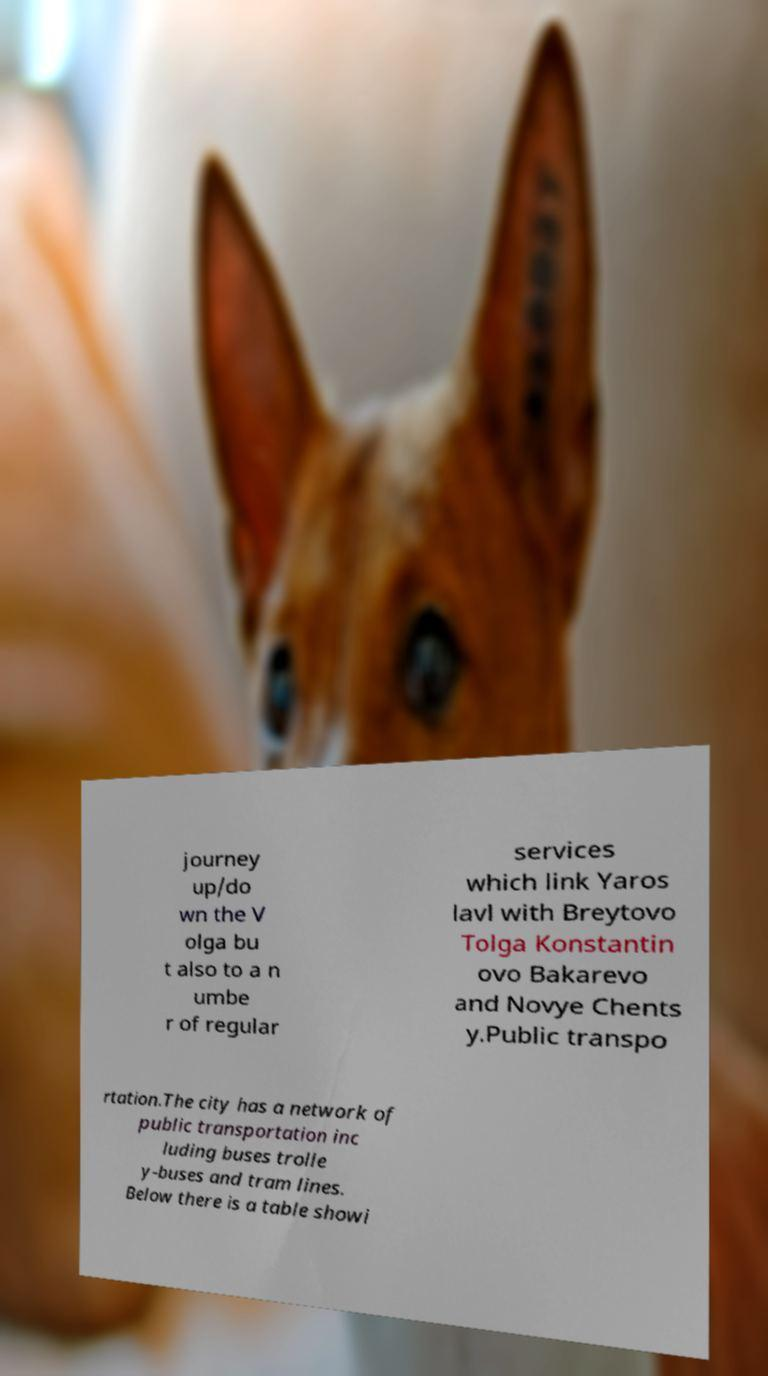Please identify and transcribe the text found in this image. journey up/do wn the V olga bu t also to a n umbe r of regular services which link Yaros lavl with Breytovo Tolga Konstantin ovo Bakarevo and Novye Chents y.Public transpo rtation.The city has a network of public transportation inc luding buses trolle y-buses and tram lines. Below there is a table showi 